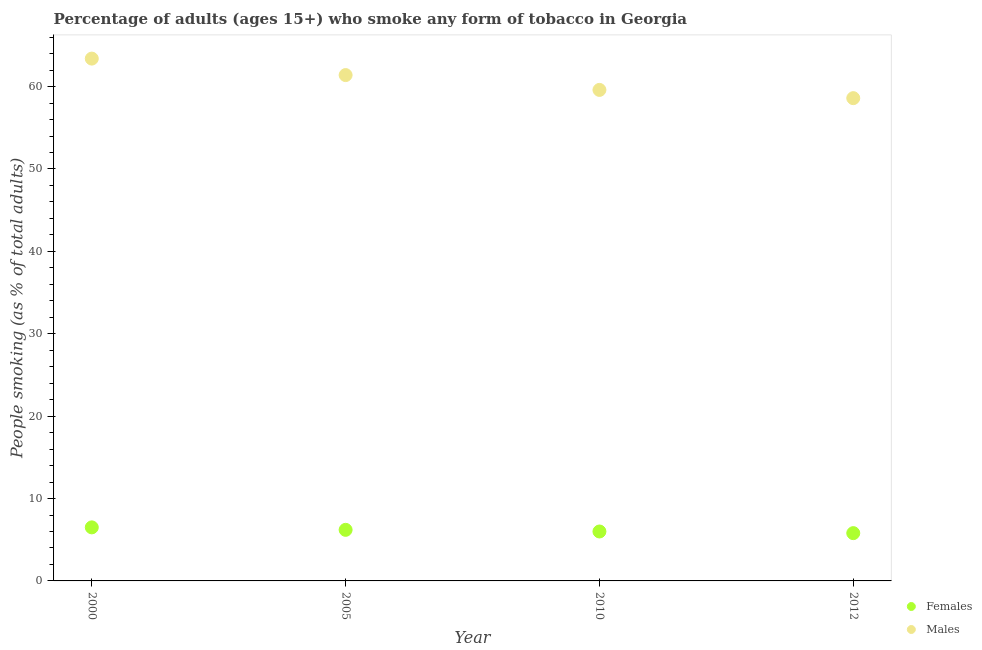What is the percentage of males who smoke in 2010?
Make the answer very short. 59.6. Across all years, what is the maximum percentage of males who smoke?
Offer a terse response. 63.4. In which year was the percentage of males who smoke maximum?
Your answer should be very brief. 2000. What is the total percentage of males who smoke in the graph?
Provide a succinct answer. 243. What is the difference between the percentage of females who smoke in 2000 and that in 2005?
Keep it short and to the point. 0.3. What is the difference between the percentage of females who smoke in 2010 and the percentage of males who smoke in 2005?
Keep it short and to the point. -55.4. What is the average percentage of females who smoke per year?
Give a very brief answer. 6.12. In the year 2000, what is the difference between the percentage of males who smoke and percentage of females who smoke?
Offer a very short reply. 56.9. What is the ratio of the percentage of females who smoke in 2000 to that in 2010?
Give a very brief answer. 1.08. Is the percentage of females who smoke in 2000 less than that in 2012?
Provide a succinct answer. No. Is the difference between the percentage of females who smoke in 2005 and 2012 greater than the difference between the percentage of males who smoke in 2005 and 2012?
Keep it short and to the point. No. What is the difference between the highest and the second highest percentage of females who smoke?
Make the answer very short. 0.3. What is the difference between the highest and the lowest percentage of females who smoke?
Provide a short and direct response. 0.7. Is the sum of the percentage of females who smoke in 2000 and 2010 greater than the maximum percentage of males who smoke across all years?
Give a very brief answer. No. Does the percentage of females who smoke monotonically increase over the years?
Make the answer very short. No. How many dotlines are there?
Your answer should be very brief. 2. What is the difference between two consecutive major ticks on the Y-axis?
Offer a very short reply. 10. Are the values on the major ticks of Y-axis written in scientific E-notation?
Give a very brief answer. No. Does the graph contain grids?
Your response must be concise. No. How are the legend labels stacked?
Ensure brevity in your answer.  Vertical. What is the title of the graph?
Offer a terse response. Percentage of adults (ages 15+) who smoke any form of tobacco in Georgia. What is the label or title of the Y-axis?
Make the answer very short. People smoking (as % of total adults). What is the People smoking (as % of total adults) of Males in 2000?
Give a very brief answer. 63.4. What is the People smoking (as % of total adults) of Males in 2005?
Ensure brevity in your answer.  61.4. What is the People smoking (as % of total adults) in Females in 2010?
Your answer should be very brief. 6. What is the People smoking (as % of total adults) of Males in 2010?
Provide a succinct answer. 59.6. What is the People smoking (as % of total adults) of Females in 2012?
Your answer should be compact. 5.8. What is the People smoking (as % of total adults) of Males in 2012?
Ensure brevity in your answer.  58.6. Across all years, what is the maximum People smoking (as % of total adults) in Females?
Provide a short and direct response. 6.5. Across all years, what is the maximum People smoking (as % of total adults) in Males?
Give a very brief answer. 63.4. Across all years, what is the minimum People smoking (as % of total adults) in Females?
Provide a succinct answer. 5.8. Across all years, what is the minimum People smoking (as % of total adults) in Males?
Provide a short and direct response. 58.6. What is the total People smoking (as % of total adults) in Females in the graph?
Ensure brevity in your answer.  24.5. What is the total People smoking (as % of total adults) in Males in the graph?
Your answer should be compact. 243. What is the difference between the People smoking (as % of total adults) of Males in 2000 and that in 2005?
Keep it short and to the point. 2. What is the difference between the People smoking (as % of total adults) of Males in 2000 and that in 2010?
Your response must be concise. 3.8. What is the difference between the People smoking (as % of total adults) in Females in 2005 and that in 2010?
Keep it short and to the point. 0.2. What is the difference between the People smoking (as % of total adults) of Males in 2005 and that in 2012?
Make the answer very short. 2.8. What is the difference between the People smoking (as % of total adults) in Males in 2010 and that in 2012?
Offer a terse response. 1. What is the difference between the People smoking (as % of total adults) of Females in 2000 and the People smoking (as % of total adults) of Males in 2005?
Keep it short and to the point. -54.9. What is the difference between the People smoking (as % of total adults) of Females in 2000 and the People smoking (as % of total adults) of Males in 2010?
Your answer should be very brief. -53.1. What is the difference between the People smoking (as % of total adults) in Females in 2000 and the People smoking (as % of total adults) in Males in 2012?
Provide a succinct answer. -52.1. What is the difference between the People smoking (as % of total adults) of Females in 2005 and the People smoking (as % of total adults) of Males in 2010?
Give a very brief answer. -53.4. What is the difference between the People smoking (as % of total adults) of Females in 2005 and the People smoking (as % of total adults) of Males in 2012?
Provide a succinct answer. -52.4. What is the difference between the People smoking (as % of total adults) of Females in 2010 and the People smoking (as % of total adults) of Males in 2012?
Offer a very short reply. -52.6. What is the average People smoking (as % of total adults) in Females per year?
Offer a very short reply. 6.12. What is the average People smoking (as % of total adults) of Males per year?
Keep it short and to the point. 60.75. In the year 2000, what is the difference between the People smoking (as % of total adults) in Females and People smoking (as % of total adults) in Males?
Provide a short and direct response. -56.9. In the year 2005, what is the difference between the People smoking (as % of total adults) in Females and People smoking (as % of total adults) in Males?
Offer a terse response. -55.2. In the year 2010, what is the difference between the People smoking (as % of total adults) of Females and People smoking (as % of total adults) of Males?
Provide a succinct answer. -53.6. In the year 2012, what is the difference between the People smoking (as % of total adults) of Females and People smoking (as % of total adults) of Males?
Your answer should be very brief. -52.8. What is the ratio of the People smoking (as % of total adults) of Females in 2000 to that in 2005?
Your response must be concise. 1.05. What is the ratio of the People smoking (as % of total adults) of Males in 2000 to that in 2005?
Provide a short and direct response. 1.03. What is the ratio of the People smoking (as % of total adults) of Females in 2000 to that in 2010?
Ensure brevity in your answer.  1.08. What is the ratio of the People smoking (as % of total adults) in Males in 2000 to that in 2010?
Offer a terse response. 1.06. What is the ratio of the People smoking (as % of total adults) in Females in 2000 to that in 2012?
Keep it short and to the point. 1.12. What is the ratio of the People smoking (as % of total adults) of Males in 2000 to that in 2012?
Provide a short and direct response. 1.08. What is the ratio of the People smoking (as % of total adults) of Females in 2005 to that in 2010?
Make the answer very short. 1.03. What is the ratio of the People smoking (as % of total adults) in Males in 2005 to that in 2010?
Ensure brevity in your answer.  1.03. What is the ratio of the People smoking (as % of total adults) in Females in 2005 to that in 2012?
Make the answer very short. 1.07. What is the ratio of the People smoking (as % of total adults) in Males in 2005 to that in 2012?
Give a very brief answer. 1.05. What is the ratio of the People smoking (as % of total adults) of Females in 2010 to that in 2012?
Keep it short and to the point. 1.03. What is the ratio of the People smoking (as % of total adults) in Males in 2010 to that in 2012?
Give a very brief answer. 1.02. What is the difference between the highest and the second highest People smoking (as % of total adults) of Females?
Provide a succinct answer. 0.3. 